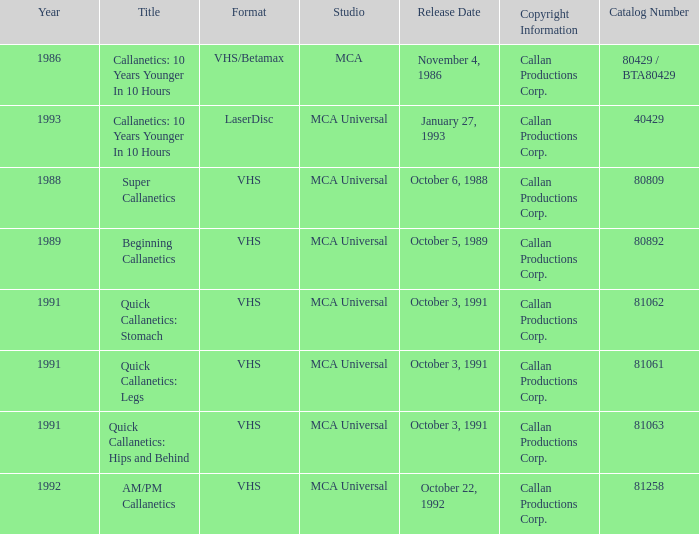Which studio corresponds to catalog number 81063? MCA Universal. 